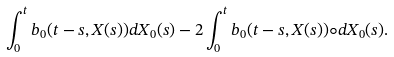Convert formula to latex. <formula><loc_0><loc_0><loc_500><loc_500>\int _ { 0 } ^ { t } b _ { 0 } ( t - s , X ( s ) ) d X _ { 0 } ( s ) - 2 \int _ { 0 } ^ { t } b _ { 0 } ( t - s , X ( s ) ) \circ d X _ { 0 } ( s ) .</formula> 